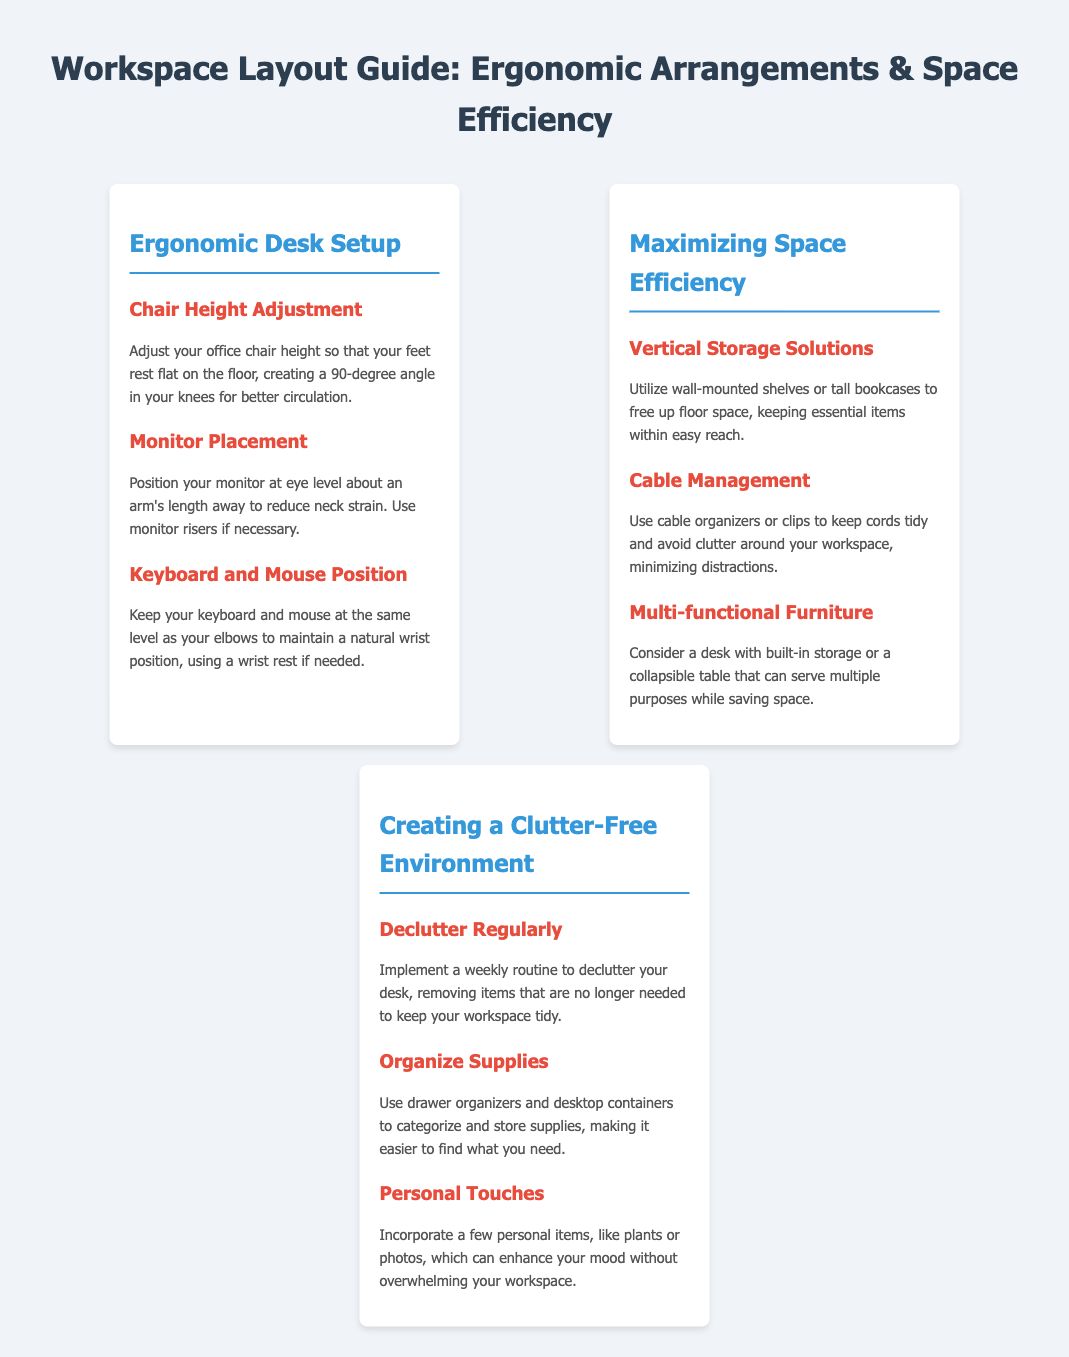what is the title of the document? The title of the document is stated at the top of the page, summarizing its purpose.
Answer: Workspace Layout Guide: Ergonomic Arrangements & Space Efficiency how many tips are provided under "Maximizing Space Efficiency"? There are three specific tips listed under the "Maximizing Space Efficiency" section.
Answer: 3 what should be the position of the monitor according to the guidelines? The guidelines suggest positioning the monitor at eye level about an arm's length away.
Answer: Eye level, arm's length what is a recommended method for organizing supplies? The document advises using drawer organizers and desktop containers to categorize and store supplies.
Answer: Drawer organizers and desktop containers what is mentioned as a personal item to enhance mood? A personal item suggested in the document is plants, which can contribute positively to the workspace.
Answer: Plants what should you do to keep your workspace tidy? The document recommends implementing a weekly routine to declutter your desk.
Answer: Implement a weekly routine which section discusses using shelves for storage? The section titled "Maximizing Space Efficiency" discusses utilizing wall-mounted shelves for storage.
Answer: Maximizing Space Efficiency how many menu items are displayed in the document? There are three main menu items presented within the document layout.
Answer: 3 